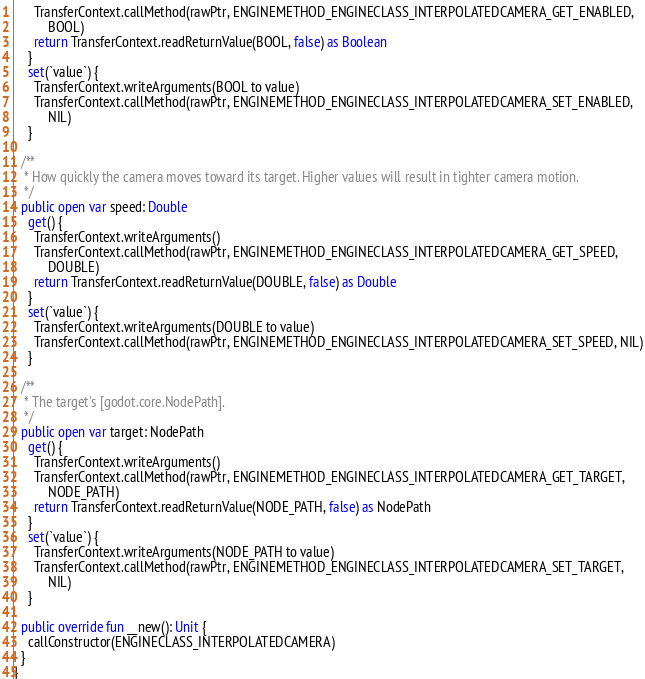<code> <loc_0><loc_0><loc_500><loc_500><_Kotlin_>      TransferContext.callMethod(rawPtr, ENGINEMETHOD_ENGINECLASS_INTERPOLATEDCAMERA_GET_ENABLED,
          BOOL)
      return TransferContext.readReturnValue(BOOL, false) as Boolean
    }
    set(`value`) {
      TransferContext.writeArguments(BOOL to value)
      TransferContext.callMethod(rawPtr, ENGINEMETHOD_ENGINECLASS_INTERPOLATEDCAMERA_SET_ENABLED,
          NIL)
    }

  /**
   * How quickly the camera moves toward its target. Higher values will result in tighter camera motion.
   */
  public open var speed: Double
    get() {
      TransferContext.writeArguments()
      TransferContext.callMethod(rawPtr, ENGINEMETHOD_ENGINECLASS_INTERPOLATEDCAMERA_GET_SPEED,
          DOUBLE)
      return TransferContext.readReturnValue(DOUBLE, false) as Double
    }
    set(`value`) {
      TransferContext.writeArguments(DOUBLE to value)
      TransferContext.callMethod(rawPtr, ENGINEMETHOD_ENGINECLASS_INTERPOLATEDCAMERA_SET_SPEED, NIL)
    }

  /**
   * The target's [godot.core.NodePath].
   */
  public open var target: NodePath
    get() {
      TransferContext.writeArguments()
      TransferContext.callMethod(rawPtr, ENGINEMETHOD_ENGINECLASS_INTERPOLATEDCAMERA_GET_TARGET,
          NODE_PATH)
      return TransferContext.readReturnValue(NODE_PATH, false) as NodePath
    }
    set(`value`) {
      TransferContext.writeArguments(NODE_PATH to value)
      TransferContext.callMethod(rawPtr, ENGINEMETHOD_ENGINECLASS_INTERPOLATEDCAMERA_SET_TARGET,
          NIL)
    }

  public override fun __new(): Unit {
    callConstructor(ENGINECLASS_INTERPOLATEDCAMERA)
  }
}
</code> 